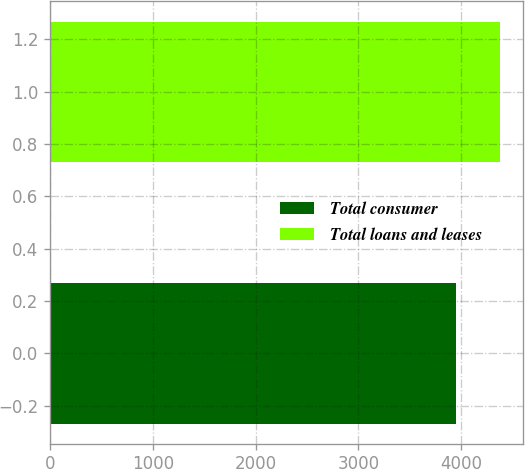Convert chart. <chart><loc_0><loc_0><loc_500><loc_500><bar_chart><fcel>Total consumer<fcel>Total loans and leases<nl><fcel>3948<fcel>4379<nl></chart> 